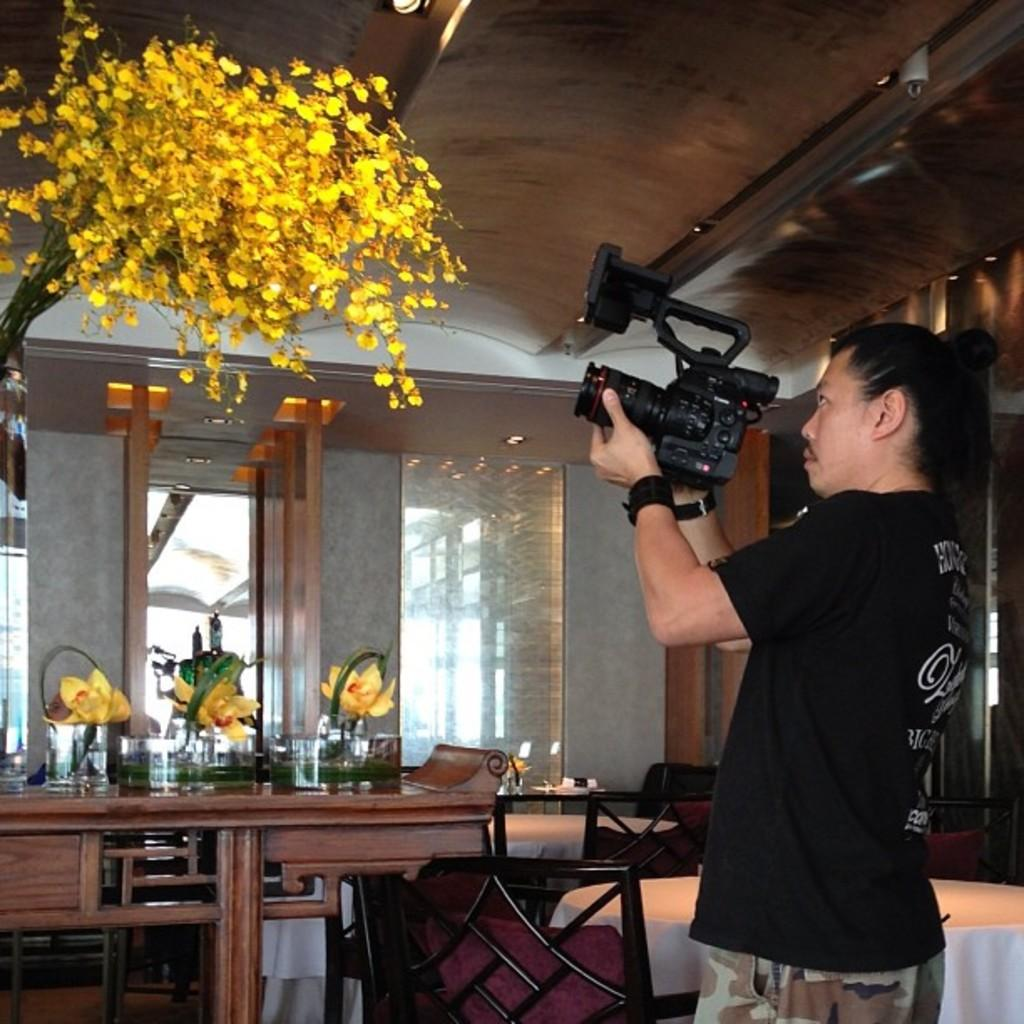What is the main subject in the image? There is a man in the image. What is the man doing in the image? The man is standing and holding a video camera in his hands. What is the man shooting with the video camera? The man is shooting flowers. Can you describe the flowers being shot? The flowers are yellow in color. What type of horn can be seen on the man's head in the image? There is no horn present on the man's head in the image. What type of spade is the man using to dig in the image? There is no spade present in the image; the man is holding a video camera and shooting flowers. 